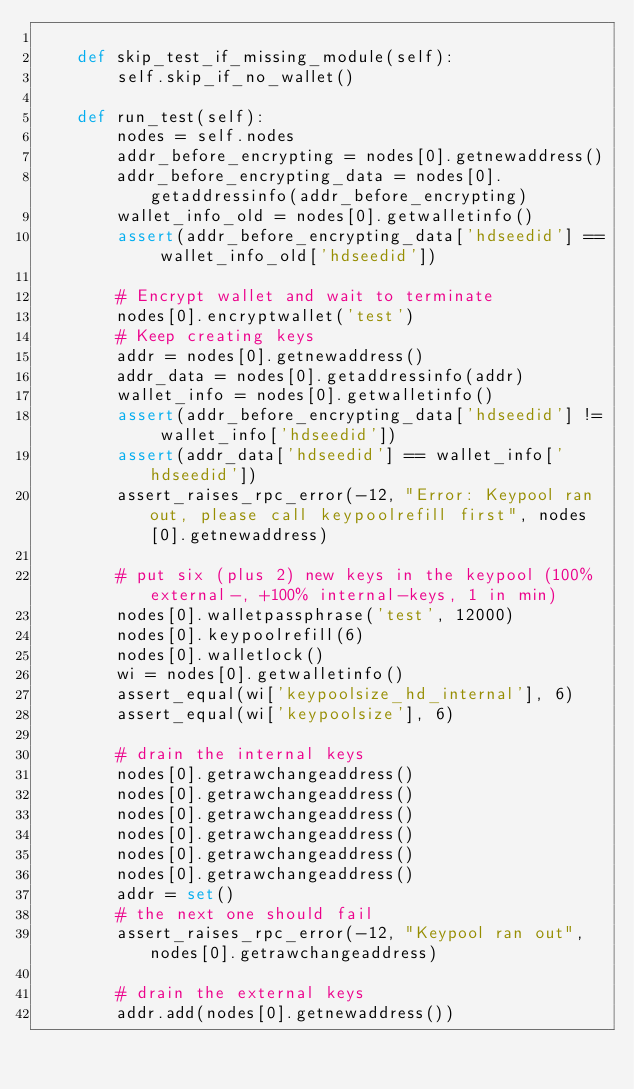<code> <loc_0><loc_0><loc_500><loc_500><_Python_>
    def skip_test_if_missing_module(self):
        self.skip_if_no_wallet()

    def run_test(self):
        nodes = self.nodes
        addr_before_encrypting = nodes[0].getnewaddress()
        addr_before_encrypting_data = nodes[0].getaddressinfo(addr_before_encrypting)
        wallet_info_old = nodes[0].getwalletinfo()
        assert(addr_before_encrypting_data['hdseedid'] == wallet_info_old['hdseedid'])

        # Encrypt wallet and wait to terminate
        nodes[0].encryptwallet('test')
        # Keep creating keys
        addr = nodes[0].getnewaddress()
        addr_data = nodes[0].getaddressinfo(addr)
        wallet_info = nodes[0].getwalletinfo()
        assert(addr_before_encrypting_data['hdseedid'] != wallet_info['hdseedid'])
        assert(addr_data['hdseedid'] == wallet_info['hdseedid'])
        assert_raises_rpc_error(-12, "Error: Keypool ran out, please call keypoolrefill first", nodes[0].getnewaddress)

        # put six (plus 2) new keys in the keypool (100% external-, +100% internal-keys, 1 in min)
        nodes[0].walletpassphrase('test', 12000)
        nodes[0].keypoolrefill(6)
        nodes[0].walletlock()
        wi = nodes[0].getwalletinfo()
        assert_equal(wi['keypoolsize_hd_internal'], 6)
        assert_equal(wi['keypoolsize'], 6)

        # drain the internal keys
        nodes[0].getrawchangeaddress()
        nodes[0].getrawchangeaddress()
        nodes[0].getrawchangeaddress()
        nodes[0].getrawchangeaddress()
        nodes[0].getrawchangeaddress()
        nodes[0].getrawchangeaddress()
        addr = set()
        # the next one should fail
        assert_raises_rpc_error(-12, "Keypool ran out", nodes[0].getrawchangeaddress)

        # drain the external keys
        addr.add(nodes[0].getnewaddress())</code> 